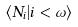<formula> <loc_0><loc_0><loc_500><loc_500>\langle N _ { i } | i < \omega \rangle</formula> 